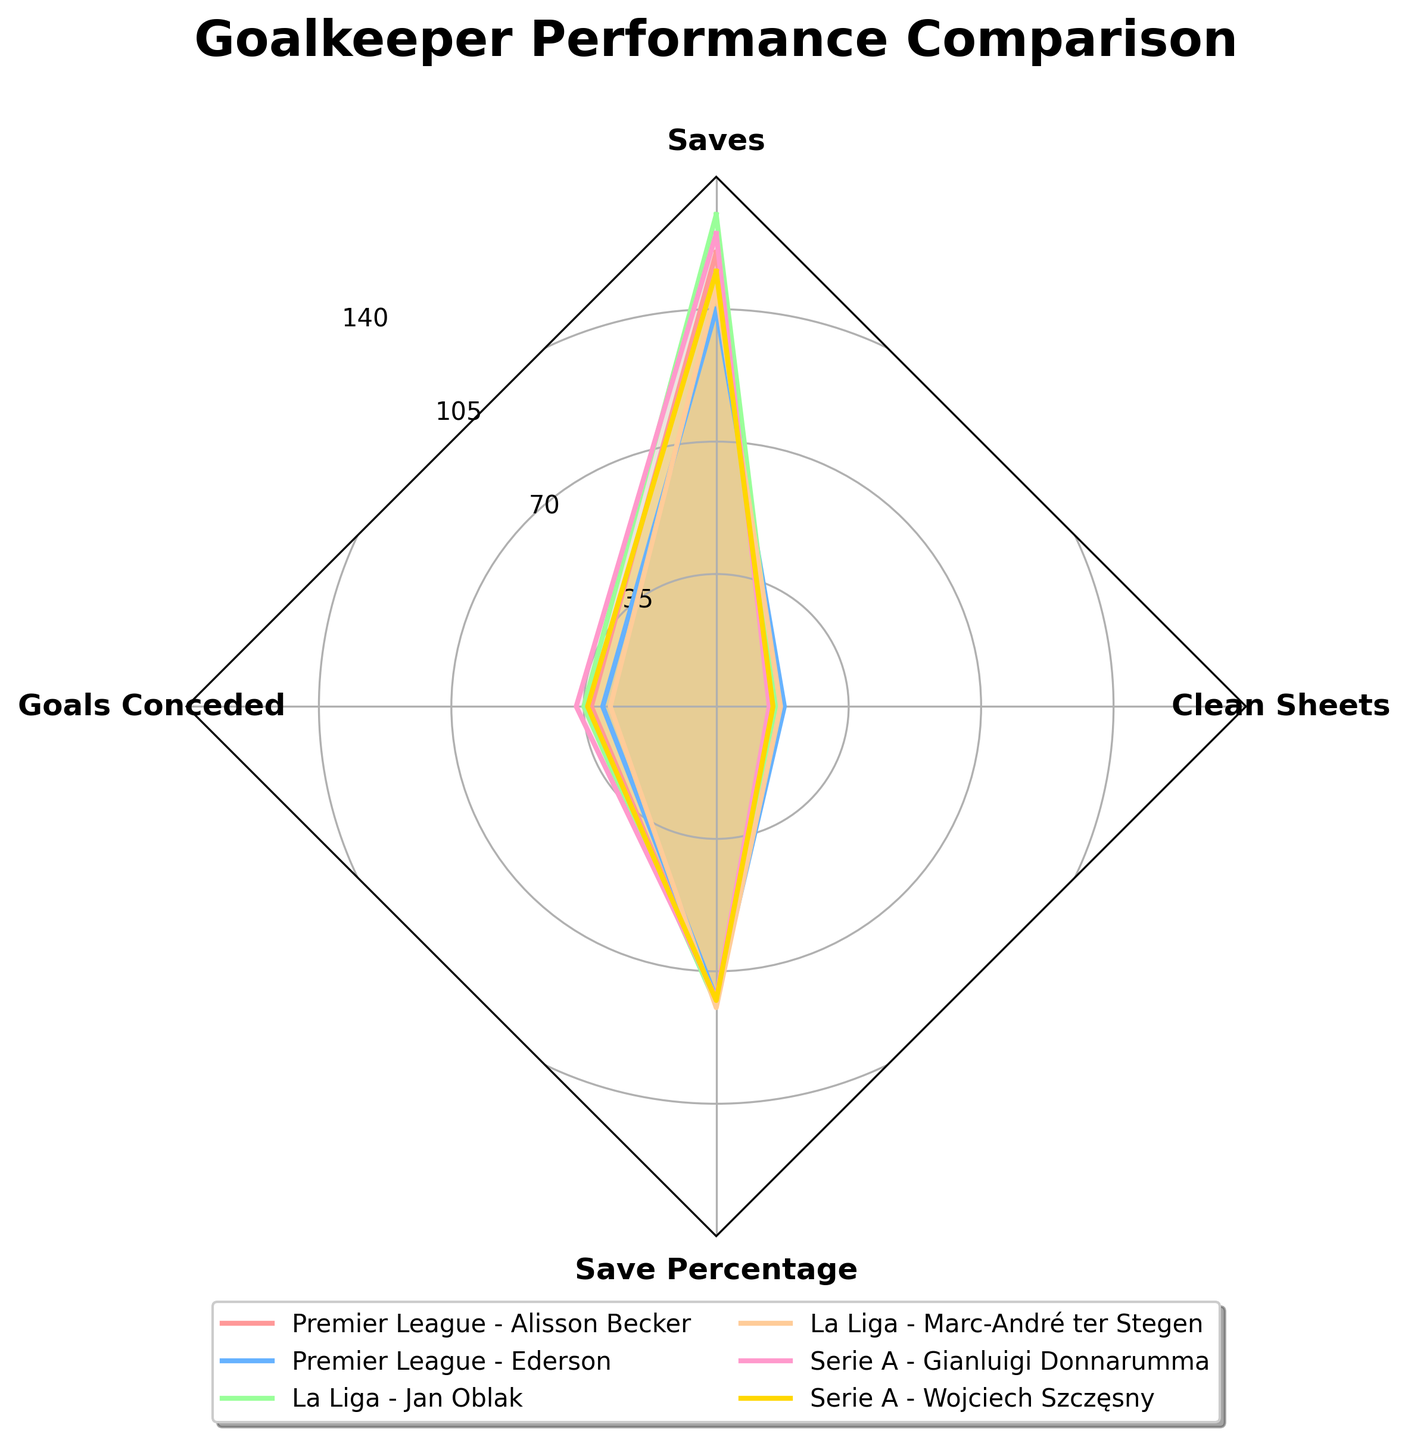What's the title of the radar chart? The title is usually at the top of the chart in a larger font. This chart has "Goalkeeper Performance Comparison" as its title, as indicated by the code that sets up the plot title.
Answer: Goalkeeper Performance Comparison How many goalkeepers are compared in the radar chart? Each goalkeeper has a separate plot in the radar chart, indicated by different colors and labels in the legend. Counting the label entries gives us six goalkeepers.
Answer: Six Which goalkeeper has achieved the highest number of clean sheets? You can identify clean sheets by looking at one of the vertices of the radar chart and finding the outermost plot on that axis. According to the data, Ederson has the highest value of 18.
Answer: Ederson How many saves does Jan Oblak have, and how does it compare to Gianluigi Donnarumma's saves? Each plot extends to different points on the 'Saves' axis. Jan Oblak has 130 saves, while Gianluigi Donnarumma has 125 saves. Comparing the two, Jan Oblak has 5 more saves than Gianluigi Donnarumma.
Answer: 130 and 125; Jan Oblak has 5 more saves What is the average save percentage of the goalkeepers? To find the average, sum the save percentages of all goalkeepers and divide by the total number of goalkeepers. The percentages are: 78.0, 77.2, 78.7, 79.6, 77.1, 77.7. The sum is 468.3 and the average is 468.3 / 6.
Answer: 78.05 Which goalkeeper from the Premier League has a higher save percentage? There are two Premier League goalkeepers: Alisson Becker and Ederson. The radar chart shows that Alisson Becker's save percentage is 78.0, while Ederson's is 77.2. Hence, Alisson Becker has a higher save percentage.
Answer: Alisson Becker How do the goalkeepers from La Liga compare in terms of goals conceded? The radar chart has a 'Goals Conceded' axis. By comparing the plots, Jan Oblak conceded 35 goals and Marc-André ter Stegen conceded 28 goals. Marc-André ter Stegen has conceded fewer goals than Jan Oblak.
Answer: Marc-André ter Stegen has conceded fewer goals Which metric shows the most variation among the goalkeepers? By visually comparing the spreads of each plot along the axes, it seems that the 'Goals Conceded' metric has the most variation, with values ranging from 28 to 37.
Answer: Goals Conceded Who has the second-highest number of saves in this comparison? By examining the 'Saves' axis, the highest number is 130 by Jan Oblak, and second-highest is 125 by Gianluigi Donnarumma.
Answer: Gianluigi Donnarumma 